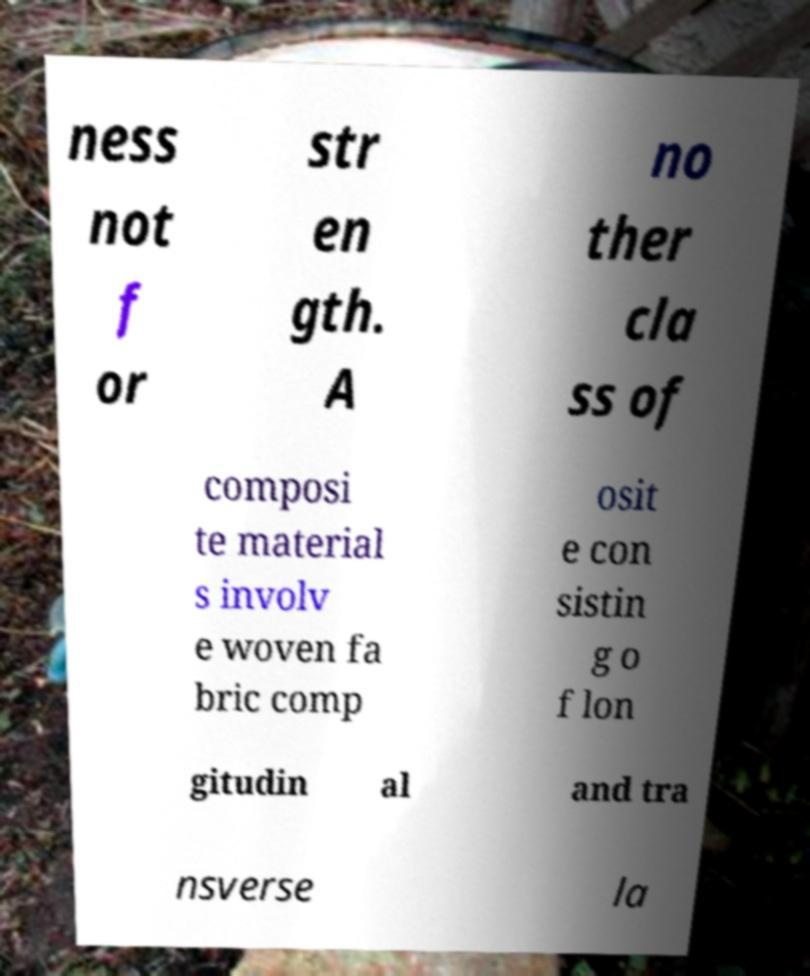Can you read and provide the text displayed in the image?This photo seems to have some interesting text. Can you extract and type it out for me? ness not f or str en gth. A no ther cla ss of composi te material s involv e woven fa bric comp osit e con sistin g o f lon gitudin al and tra nsverse la 